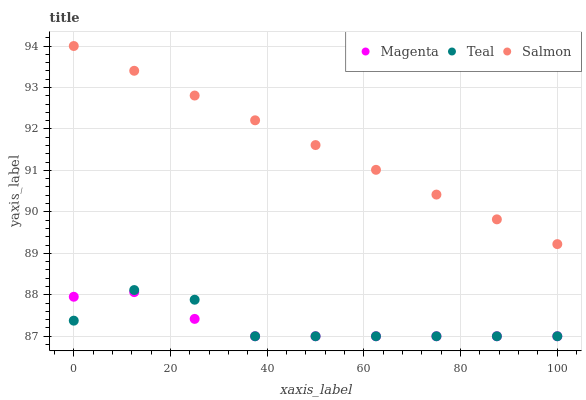Does Magenta have the minimum area under the curve?
Answer yes or no. Yes. Does Salmon have the maximum area under the curve?
Answer yes or no. Yes. Does Teal have the minimum area under the curve?
Answer yes or no. No. Does Teal have the maximum area under the curve?
Answer yes or no. No. Is Salmon the smoothest?
Answer yes or no. Yes. Is Teal the roughest?
Answer yes or no. Yes. Is Teal the smoothest?
Answer yes or no. No. Is Salmon the roughest?
Answer yes or no. No. Does Magenta have the lowest value?
Answer yes or no. Yes. Does Salmon have the lowest value?
Answer yes or no. No. Does Salmon have the highest value?
Answer yes or no. Yes. Does Teal have the highest value?
Answer yes or no. No. Is Teal less than Salmon?
Answer yes or no. Yes. Is Salmon greater than Magenta?
Answer yes or no. Yes. Does Teal intersect Magenta?
Answer yes or no. Yes. Is Teal less than Magenta?
Answer yes or no. No. Is Teal greater than Magenta?
Answer yes or no. No. Does Teal intersect Salmon?
Answer yes or no. No. 